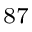<formula> <loc_0><loc_0><loc_500><loc_500>^ { 8 7 }</formula> 